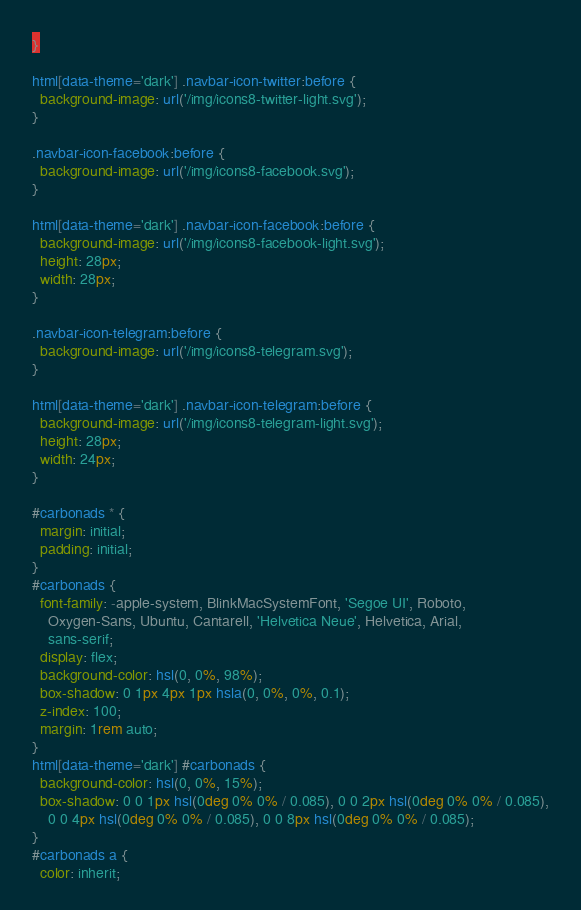<code> <loc_0><loc_0><loc_500><loc_500><_CSS_>}

html[data-theme='dark'] .navbar-icon-twitter:before {
  background-image: url('/img/icons8-twitter-light.svg');
}

.navbar-icon-facebook:before {
  background-image: url('/img/icons8-facebook.svg');
}

html[data-theme='dark'] .navbar-icon-facebook:before {
  background-image: url('/img/icons8-facebook-light.svg');
  height: 28px;
  width: 28px;
}

.navbar-icon-telegram:before {
  background-image: url('/img/icons8-telegram.svg');
}

html[data-theme='dark'] .navbar-icon-telegram:before {
  background-image: url('/img/icons8-telegram-light.svg');
  height: 28px;
  width: 24px;
}

#carbonads * {
  margin: initial;
  padding: initial;
}
#carbonads {
  font-family: -apple-system, BlinkMacSystemFont, 'Segoe UI', Roboto,
    Oxygen-Sans, Ubuntu, Cantarell, 'Helvetica Neue', Helvetica, Arial,
    sans-serif;
  display: flex;
  background-color: hsl(0, 0%, 98%);
  box-shadow: 0 1px 4px 1px hsla(0, 0%, 0%, 0.1);
  z-index: 100;
  margin: 1rem auto;
}
html[data-theme='dark'] #carbonads {
  background-color: hsl(0, 0%, 15%);
  box-shadow: 0 0 1px hsl(0deg 0% 0% / 0.085), 0 0 2px hsl(0deg 0% 0% / 0.085),
    0 0 4px hsl(0deg 0% 0% / 0.085), 0 0 8px hsl(0deg 0% 0% / 0.085);
}
#carbonads a {
  color: inherit;</code> 